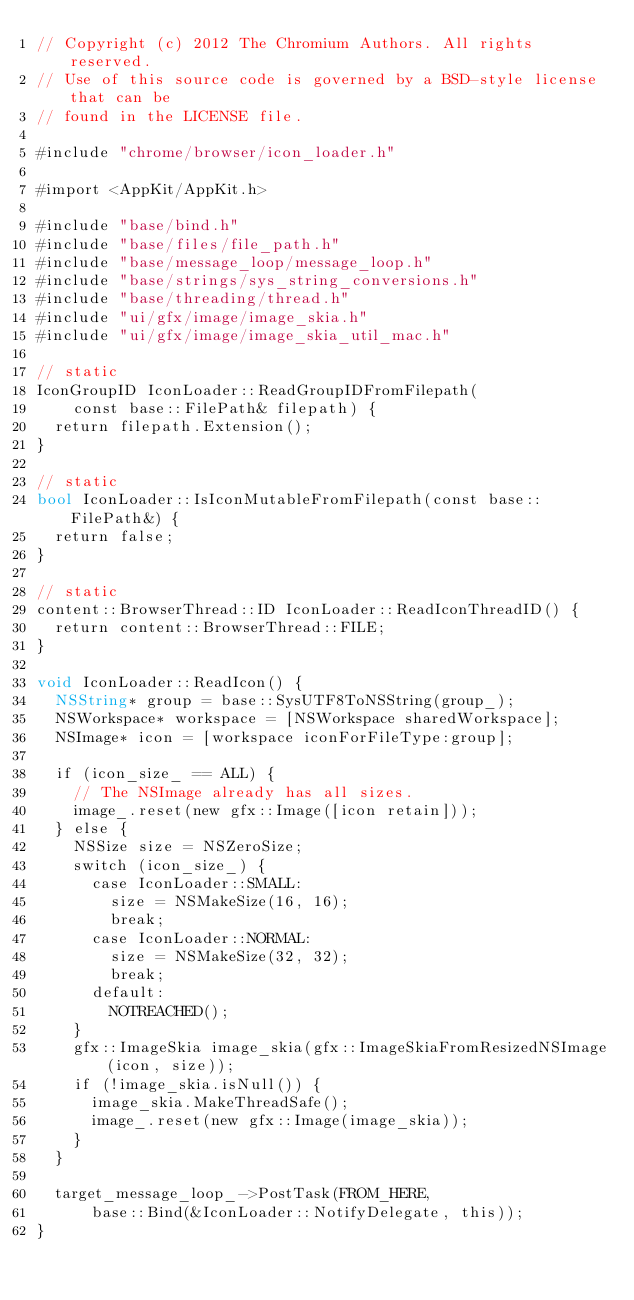<code> <loc_0><loc_0><loc_500><loc_500><_ObjectiveC_>// Copyright (c) 2012 The Chromium Authors. All rights reserved.
// Use of this source code is governed by a BSD-style license that can be
// found in the LICENSE file.

#include "chrome/browser/icon_loader.h"

#import <AppKit/AppKit.h>

#include "base/bind.h"
#include "base/files/file_path.h"
#include "base/message_loop/message_loop.h"
#include "base/strings/sys_string_conversions.h"
#include "base/threading/thread.h"
#include "ui/gfx/image/image_skia.h"
#include "ui/gfx/image/image_skia_util_mac.h"

// static
IconGroupID IconLoader::ReadGroupIDFromFilepath(
    const base::FilePath& filepath) {
  return filepath.Extension();
}

// static
bool IconLoader::IsIconMutableFromFilepath(const base::FilePath&) {
  return false;
}

// static
content::BrowserThread::ID IconLoader::ReadIconThreadID() {
  return content::BrowserThread::FILE;
}

void IconLoader::ReadIcon() {
  NSString* group = base::SysUTF8ToNSString(group_);
  NSWorkspace* workspace = [NSWorkspace sharedWorkspace];
  NSImage* icon = [workspace iconForFileType:group];

  if (icon_size_ == ALL) {
    // The NSImage already has all sizes.
    image_.reset(new gfx::Image([icon retain]));
  } else {
    NSSize size = NSZeroSize;
    switch (icon_size_) {
      case IconLoader::SMALL:
        size = NSMakeSize(16, 16);
        break;
      case IconLoader::NORMAL:
        size = NSMakeSize(32, 32);
        break;
      default:
        NOTREACHED();
    }
    gfx::ImageSkia image_skia(gfx::ImageSkiaFromResizedNSImage(icon, size));
    if (!image_skia.isNull()) {
      image_skia.MakeThreadSafe();
      image_.reset(new gfx::Image(image_skia));
    }
  }

  target_message_loop_->PostTask(FROM_HERE,
      base::Bind(&IconLoader::NotifyDelegate, this));
}
</code> 